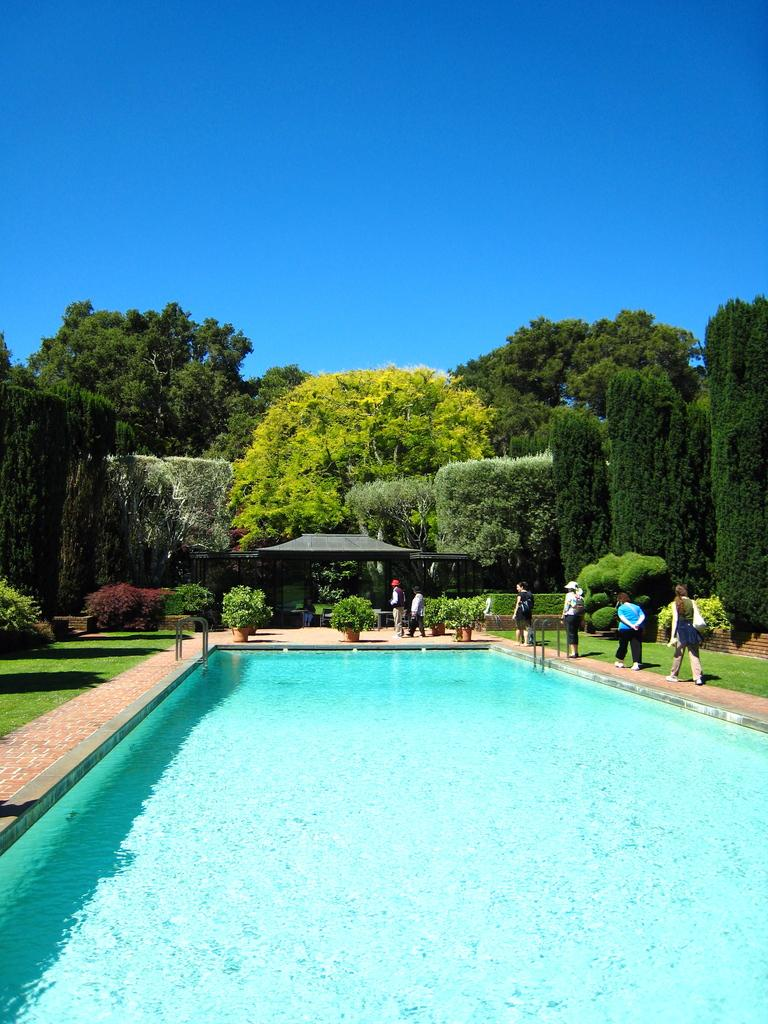What can be seen in the foreground of the picture? In the foreground of the picture, there are plants, people, grass, and a swimming pool. What is located in the center of the picture? In the center of the picture, there are trees and a construction. How would you describe the weather in the image? The sky is sunny, indicating a clear and likely warm day. Can you see any oil leaking from the construction site in the image? There is no mention of oil or any leakage in the image, so we cannot answer that question. Is there a net used for fishing in the lake in the image? There is no lake present in the image, so we cannot answer that question. 